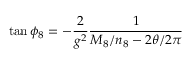<formula> <loc_0><loc_0><loc_500><loc_500>\tan \phi _ { 8 } = - { \frac { 2 } { g ^ { 2 } } } { \frac { 1 } { M _ { 8 } / n _ { 8 } - 2 \theta / 2 \pi } }</formula> 